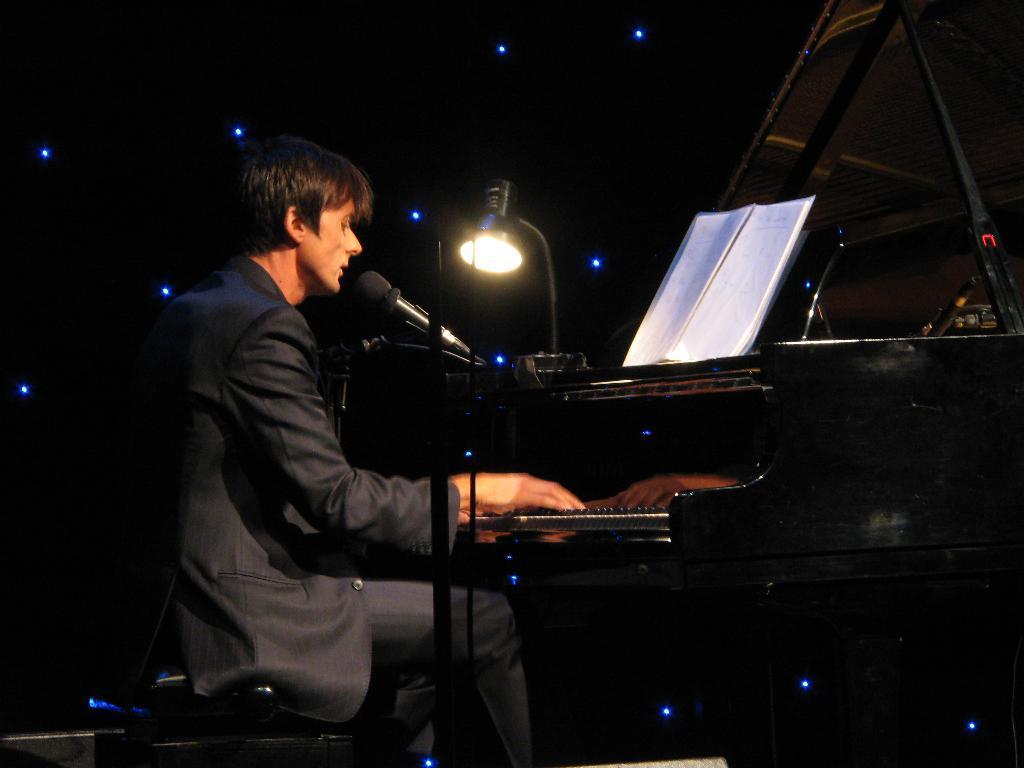Describe this image in one or two sentences. A person wearing a black coat is sitting on a stool and singing. And he is playing a piano. There is a mic with a mic stand. On the piano there is a book and a lamp. 